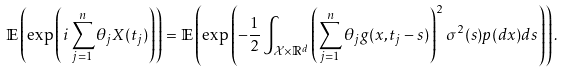<formula> <loc_0><loc_0><loc_500><loc_500>\mathbb { E } \left ( \exp \left ( i \sum _ { j = 1 } ^ { n } \theta _ { j } X ( t _ { j } ) \right ) \right ) = \mathbb { E } \left ( \exp \left ( - \frac { 1 } { 2 } \int _ { \mathcal { X } \times \mathbb { R } ^ { d } } \left ( \sum _ { j = 1 } ^ { n } \theta _ { j } g ( x , t _ { j } - s ) \right ) ^ { 2 } \sigma ^ { 2 } ( s ) p ( d x ) d s \right ) \right ) .</formula> 